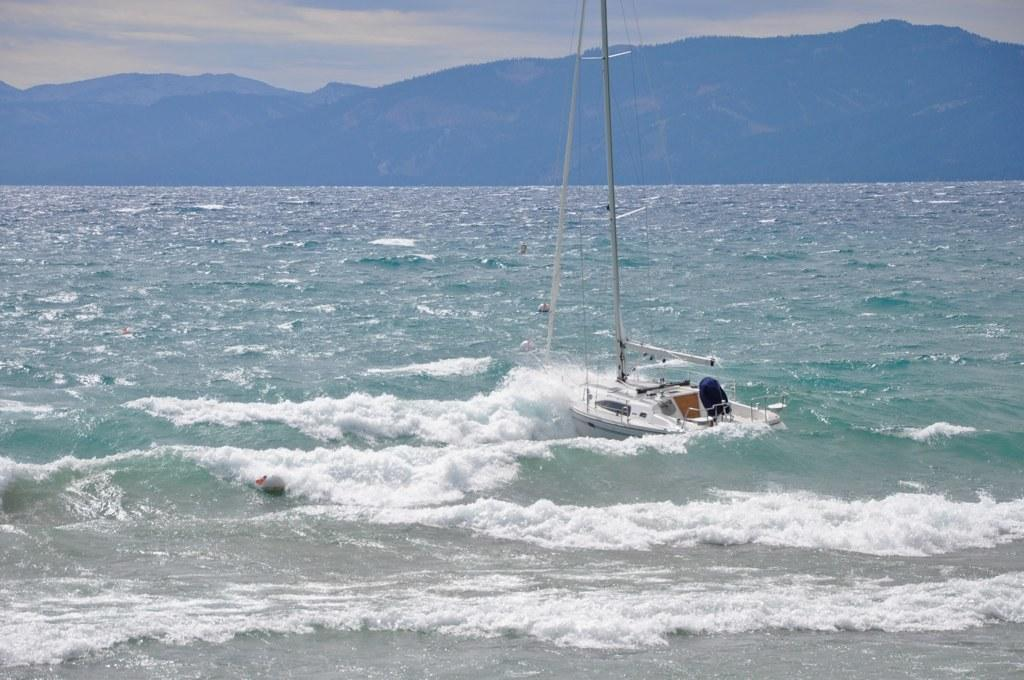What is the main subject of the image? The main subject of the image is a boat. Where is the boat located? The boat is on the water. What can be seen in the background of the image? There are mountains visible in the image. How would you describe the color of the sky in the image? The sky is blue and white in color. What type of statement is being made by the boat in the image? The boat is not making any statements in the image; it is an inanimate object. 